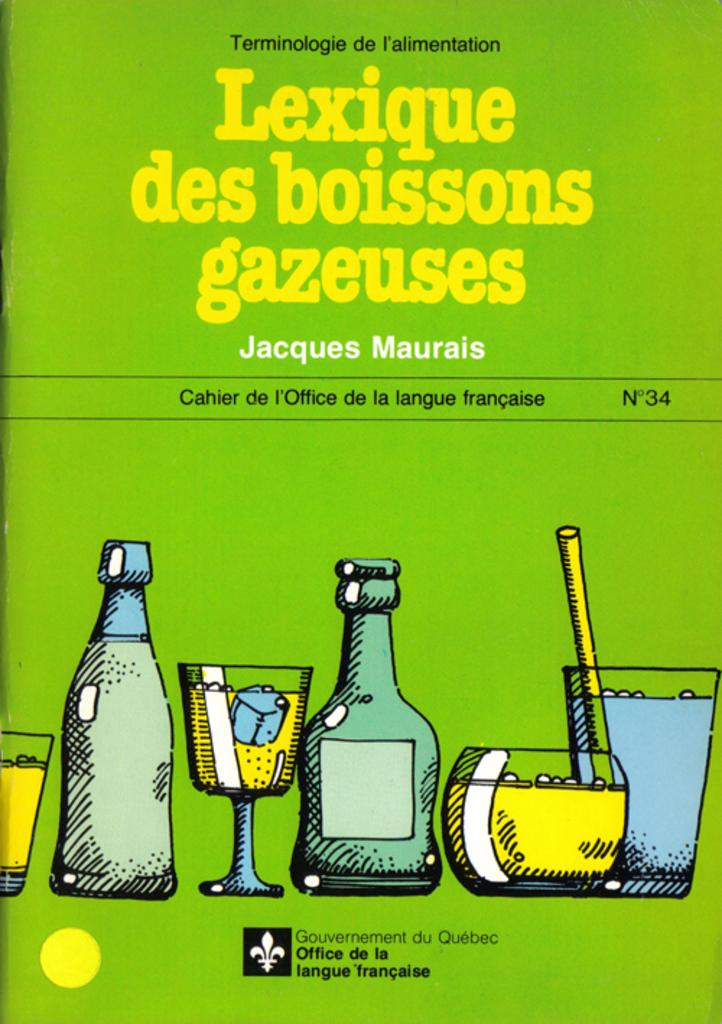Provide a one-sentence caption for the provided image. Jacques Maurais has written issue number 34 of this publication from the government of Quebec. 